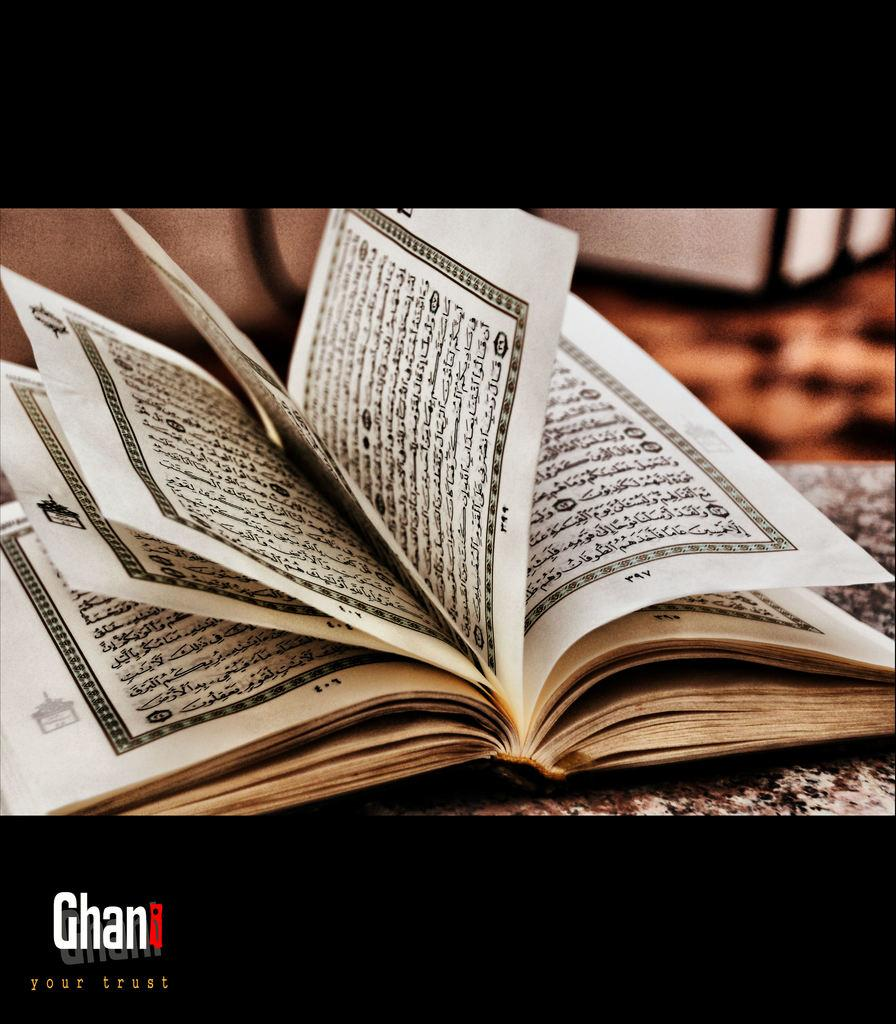Provide a one-sentence caption for the provided image. a book with ellegible writing on the pages of it, and a logo that says Ghan on the bottom left corner. 